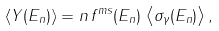Convert formula to latex. <formula><loc_0><loc_0><loc_500><loc_500>\left < Y ( E _ { n } ) \right > = n \, f ^ { m s } ( E _ { n } ) \, \left < \sigma _ { \gamma } ( E _ { n } ) \right > ,</formula> 